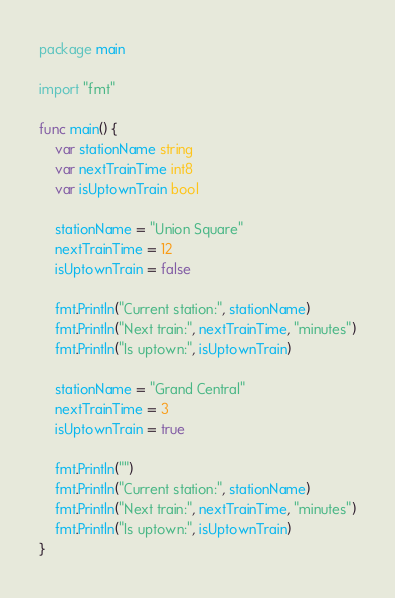<code> <loc_0><loc_0><loc_500><loc_500><_Go_>package main

import "fmt"

func main() {
	var stationName string
	var nextTrainTime int8
	var isUptownTrain bool

	stationName = "Union Square"
	nextTrainTime = 12
	isUptownTrain = false

	fmt.Println("Current station:", stationName)
	fmt.Println("Next train:", nextTrainTime, "minutes")
	fmt.Println("Is uptown:", isUptownTrain)

	stationName = "Grand Central"
	nextTrainTime = 3
	isUptownTrain = true

	fmt.Println("")
	fmt.Println("Current station:", stationName)
	fmt.Println("Next train:", nextTrainTime, "minutes")
	fmt.Println("Is uptown:", isUptownTrain)
}
</code> 